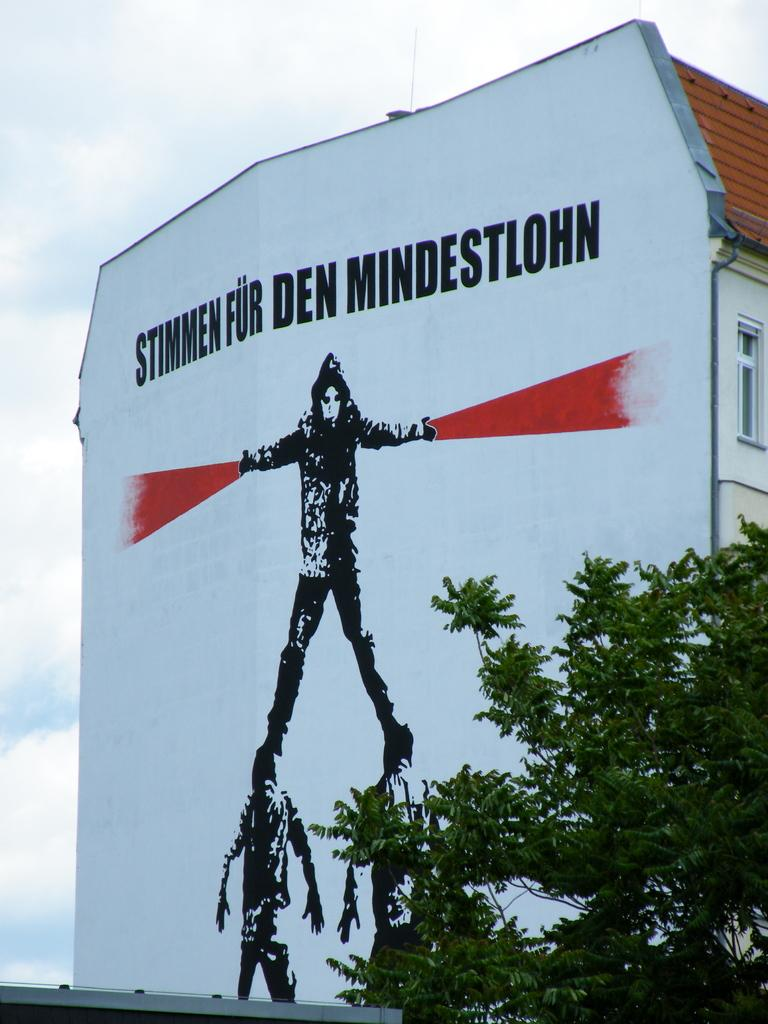What type of structure is present in the image? There is a building in the image. What can be seen on the building? The building has paintings of persons and text on it. Where is the tree located in the image? The tree is in the bottom right corner of the image. What is visible at the top of the image? The sky is visible at the top of the image, and there are clouds in the sky. What type of vase is placed on the building in the image? There is no vase present on the building in the image. Can you tell me the credit score of the person depicted in the painting on the building? There is no information about the credit score of the person depicted in the painting on the building, as credit scores are not visible in the image. 